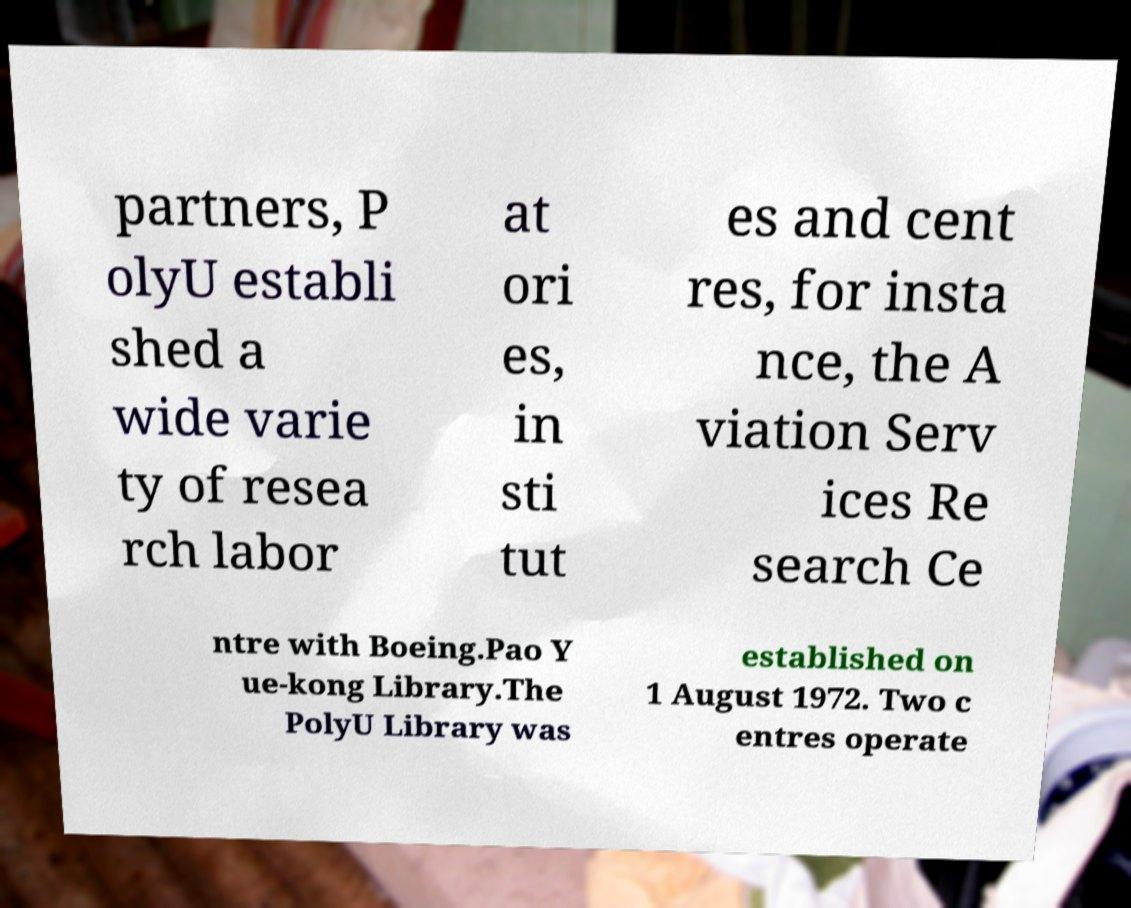What messages or text are displayed in this image? I need them in a readable, typed format. partners, P olyU establi shed a wide varie ty of resea rch labor at ori es, in sti tut es and cent res, for insta nce, the A viation Serv ices Re search Ce ntre with Boeing.Pao Y ue-kong Library.The PolyU Library was established on 1 August 1972. Two c entres operate 